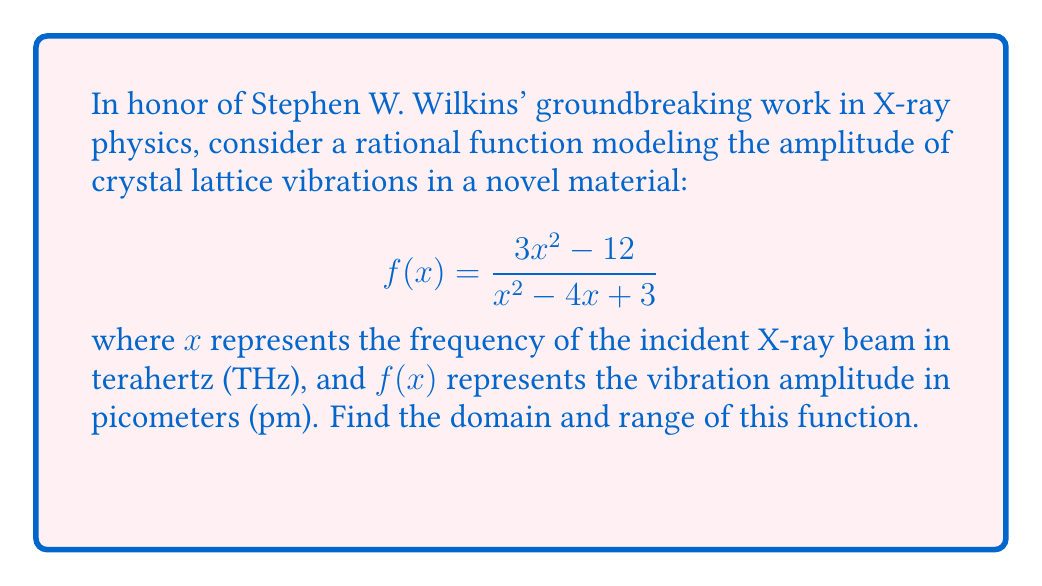Teach me how to tackle this problem. To find the domain and range of this rational function, we'll follow these steps:

1) Domain:
   The domain consists of all real numbers except those that make the denominator zero.
   Set the denominator to zero and solve:
   $$x^2 - 4x + 3 = 0$$
   $$(x - 1)(x - 3) = 0$$
   $$x = 1 \text{ or } x = 3$$

   Therefore, the domain is all real numbers except 1 and 3.

2) Range:
   a) Find the horizontal asymptote:
      As $x \to \infty$, $f(x) \to 3$
      
   b) Find the vertical asymptotes:
      At $x = 1$ and $x = 3$, $f(x)$ approaches $\infty$ or $-\infty$
      
   c) Find critical points:
      Differentiate $f(x)$ and set to zero:
      $$f'(x) = \frac{(3x^2 - 12)'(x^2 - 4x + 3) - (3x^2 - 12)(x^2 - 4x + 3)'}{(x^2 - 4x + 3)^2} = 0$$
      $$\frac{6x(x^2 - 4x + 3) - (3x^2 - 12)(2x - 4)}{(x^2 - 4x + 3)^2} = 0$$
      Solving this equation gives $x = 2$

   d) Evaluate $f(2)$:
      $$f(2) = \frac{3(2)^2 - 12}{2^2 - 4(2) + 3} = 0$$

The function approaches $\infty$ from one side and $-\infty$ from the other side of each vertical asymptote. It also reaches 0 at $x = 2$ and approaches 3 as $x \to \infty$.

Therefore, the range is all real numbers.
Answer: Domain: $\{x \in \mathbb{R} : x \neq 1 \text{ and } x \neq 3\}$
Range: $\mathbb{R}$ 